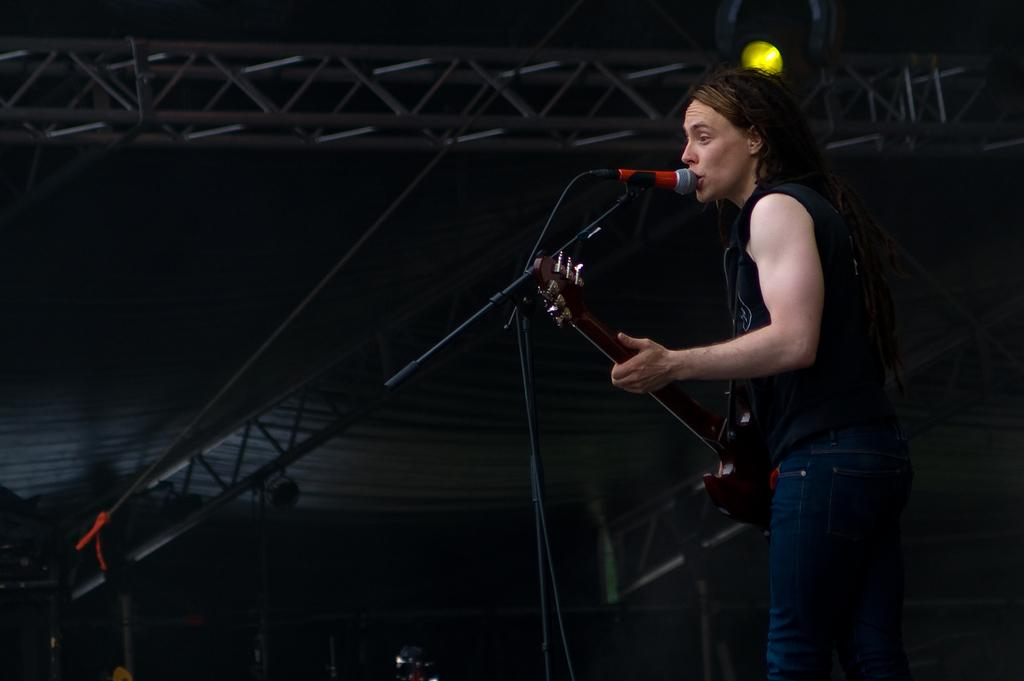Who is the main subject in the image? There is a woman in the image. What is the woman doing in the image? The woman is singing. What is the woman holding in the image? The woman is holding a microphone and a guitar. What can be seen in the background of the image? There is a stand and a light in the background of the image. What type of ornament is hanging from the guitar in the image? There is no ornament hanging from the guitar in the image. What role does the governor play in the image? There is no governor present in the image. 